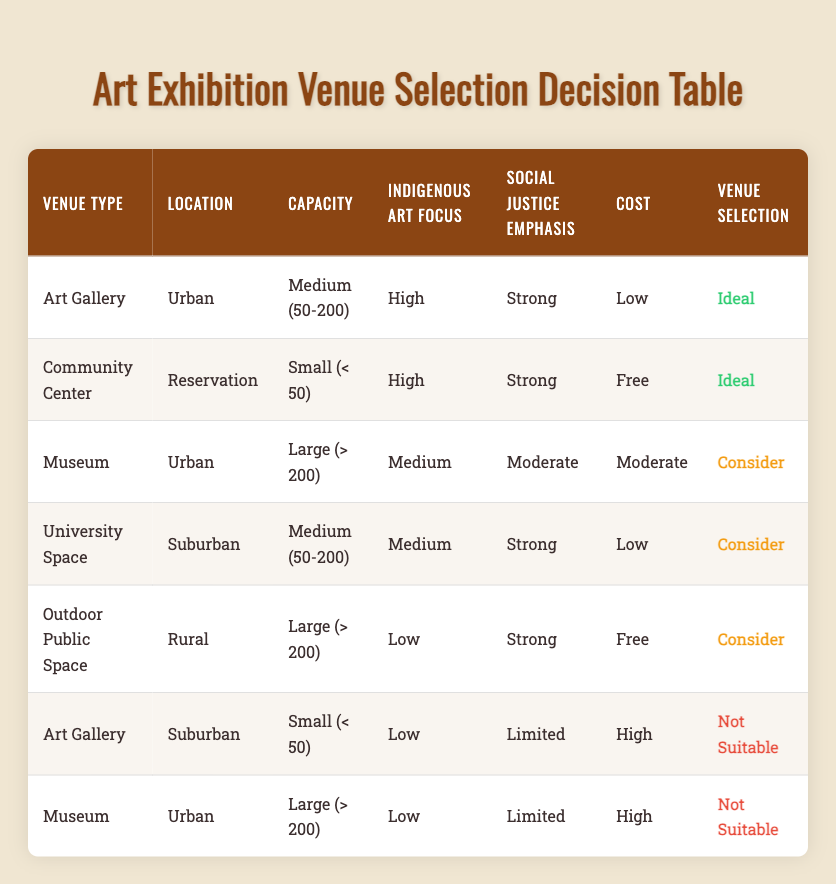What is the most suitable venue type for an exhibition focused on Indigenous art and social justice in an urban location? The table shows that an "Art Gallery" in an "Urban" location with a "Medium (50-200)" capacity, "High" Indigenous Art Focus, and "Strong" Social Justice Emphasis is considered "Ideal." Hence, the "Art Gallery" is the most suitable venue type.
Answer: Art Gallery For which venue type and location is a small capacity exhibition considered ideal? According to the table, a "Community Center" located on a "Reservation" with a "Small (< 50)" capacity, "High" Indigenous Art Focus, "Strong" Social Justice Emphasis, and "Free" cost is marked as "Ideal." Thus, the combination of Community Center and Reservation fits this criterion.
Answer: Community Center, Reservation Is a large exhibition in a Museum with a low Indigenous art focus and limited social justice emphasis considered suitable? The table indicates that a "Museum" located in an "Urban" area with "Large (> 200)" capacity, "Low" Indigenous Art Focus, and "Limited" Social Justice Emphasis is marked as "Not Suitable." Therefore, the answer is no, this combination is not suitable.
Answer: No How many venues are marked as "Consider" for an exhibition with a strong emphasis on social justice? The table reveals three venues: "Museum" (Urban, Large), "University Space" (Suburban, Medium), and "Outdoor Public Space" (Rural, Large) that receive a "Consider" rating with a strong social justice emphasis. Hence, there are three venues in total.
Answer: 3 What are the differences in venue selection based on varying capacities for an Urban Museum? The "Museum" in an "Urban" location is deemed "Consider" when it has a "Large (> 200)" capacity with a "Medium" Indigenous Art Focus and "Moderate" Social Justice Emphasis. However, the same venue with a "Large (> 200)" capacity and "Low" Indigenous Art Focus alongside "Limited" Social Justice Emphasis is classified as "Not Suitable." Thus, based on Indigenous art focus and social justice emphasis, the same venue receives different suitability ratings based on capacity.
Answer: Different suitability ratings based on focus and emphasis Is an Outdoor Public Space with a large capacity and low Indigenous art focus considered suitable for social justice emphasis? The table states that an "Outdoor Public Space" with "Large (> 200)" capacity and "Low" Indigenous Art Focus alongside a "Strong" Social Justice Emphasis is marked as "Consider." Therefore, it is indeed considered suitable.
Answer: Yes 